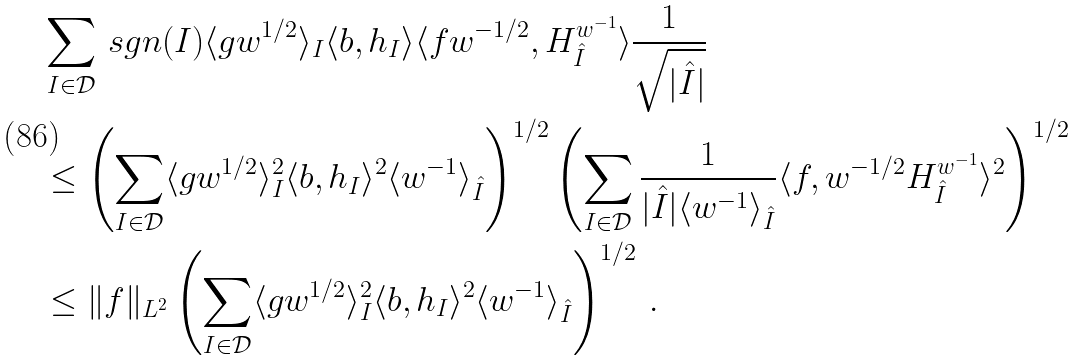<formula> <loc_0><loc_0><loc_500><loc_500>& \sum _ { I \in \mathcal { D } } \, s g n ( I ) \langle g w ^ { 1 / 2 } \rangle _ { I } \langle b , h _ { I } \rangle \langle f w ^ { - 1 / 2 } , H ^ { w ^ { - 1 } } _ { \hat { I } } \rangle \frac { 1 } { \sqrt { | \hat { I } | } } \\ & \leq \left ( \sum _ { I \in \mathcal { D } } \langle g w ^ { 1 / 2 } \rangle _ { I } ^ { 2 } \langle b , h _ { I } \rangle ^ { 2 } \langle w ^ { - 1 } \rangle _ { \hat { I } } \right ) ^ { 1 / 2 } \left ( \sum _ { I \in \mathcal { D } } \frac { 1 } { | \hat { I } | \langle w ^ { - 1 } \rangle _ { \hat { I } } } \langle f , w ^ { - 1 / 2 } H ^ { w ^ { - 1 } } _ { \hat { I } } \rangle ^ { 2 } \right ) ^ { 1 / 2 } \\ & \leq \| f \| _ { L ^ { 2 } } \left ( \sum _ { I \in \mathcal { D } } \langle g w ^ { 1 / 2 } \rangle _ { I } ^ { 2 } \langle b , h _ { I } \rangle ^ { 2 } \langle w ^ { - 1 } \rangle _ { \hat { I } } \right ) ^ { 1 / 2 } \, .</formula> 